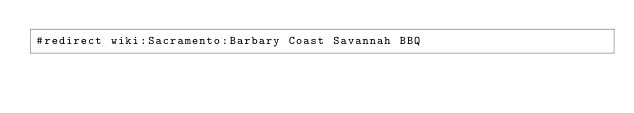Convert code to text. <code><loc_0><loc_0><loc_500><loc_500><_FORTRAN_>#redirect wiki:Sacramento:Barbary Coast Savannah BBQ
</code> 